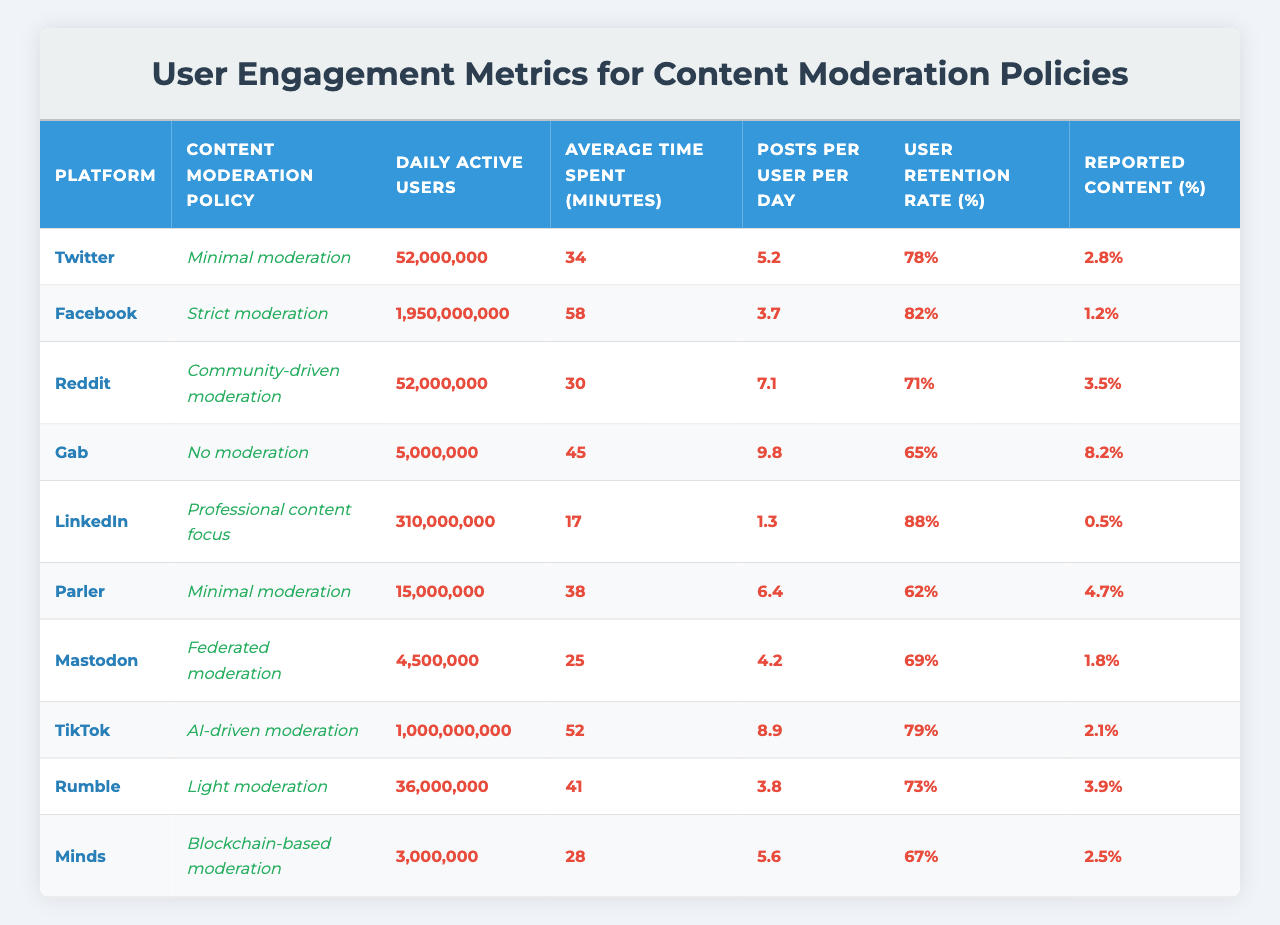What is the platform with the highest number of Daily Active Users? By reviewing the "Daily Active Users" column, we find that Facebook has the highest value, listed at 1,950,000,000 users.
Answer: Facebook Which platform has the lowest User Retention Rate? Looking at the "User Retention Rate" column, Gab has the lowest percentage at 65%.
Answer: Gab What is the average time spent on Twitter? The "Average Time Spent" for Twitter is reported as 34 minutes as indicated in the respective column.
Answer: 34 minutes Calculate the sum of Daily Active Users for all platforms. We add up all the Daily Active Users: 52,000,000 (Twitter) + 1,950,000,000 (Facebook) + 52,000,000 (Reddit) + 5,000,000 (Gab) + 310,000,000 (LinkedIn) + 15,000,000 (Parler) + 4,500,000 (Mastodon) + 1,000,000,000 (TikTok) + 36,000,000 (Rumble) + 3,000,000 (Minds) = 3,234,500,000.
Answer: 3,234,500,000 Which platform has the highest Reported Content percentage? By checking the "Reported Content" column, Gab has the highest at 8.2%.
Answer: Gab Does TikTok have a higher User Retention Rate than LinkedIn? TikTok has a User Retention Rate of 79%, while LinkedIn's is 88%. Since 79% is less than 88%, the statement is false.
Answer: No What is the median number of Posts per User per Day across the platforms? First, listing the Posts per User per Day values: 5.2, 3.7, 7.1, 9.8, 1.3, 6.4, 4.2, 8.9, 3.8, 5.6. Then, sorting these values gives: 1.3, 3.7, 3.8, 4.2, 5.2, 5.6, 6.4, 7.1, 8.9, 9.8. Since there are 10 values, the median is the average of the 5th and 6th values (5.2 and 5.6), which is (5.2 + 5.6) / 2 = 5.4.
Answer: 5.4 Which content moderation policy has the highest average time spent by users? Checking the "Average Time Spent" column, Gab has the highest average time at 45 minutes.
Answer: Gab Does the correlation between User Retention Rate and Reported Content trend show that platforms with lower moderation have higher reported content percentages? Analyzing the relationship, Gab has both the lowest User Retention Rate (65%) and the highest reported content (8.2%). Parler, with minimal moderation, shows lower retention (62%) and a reported content rate of 4.7%. Thus, it suggests that lower retention aligns with higher reported content, indicating a possible correlation.
Answer: Yes, a correlation exists What is the total reported content percentage for all platforms combined? The percentages are summed for all platforms: 2.8 (Twitter) + 1.2 (Facebook) + 3.5 (Reddit) + 8.2 (Gab) + 0.5 (LinkedIn) + 4.7 (Parler) + 1.8 (Mastodon) + 2.1 (TikTok) + 3.9 (Rumble) + 2.5 (Minds) = 30.7%.
Answer: 30.7% 